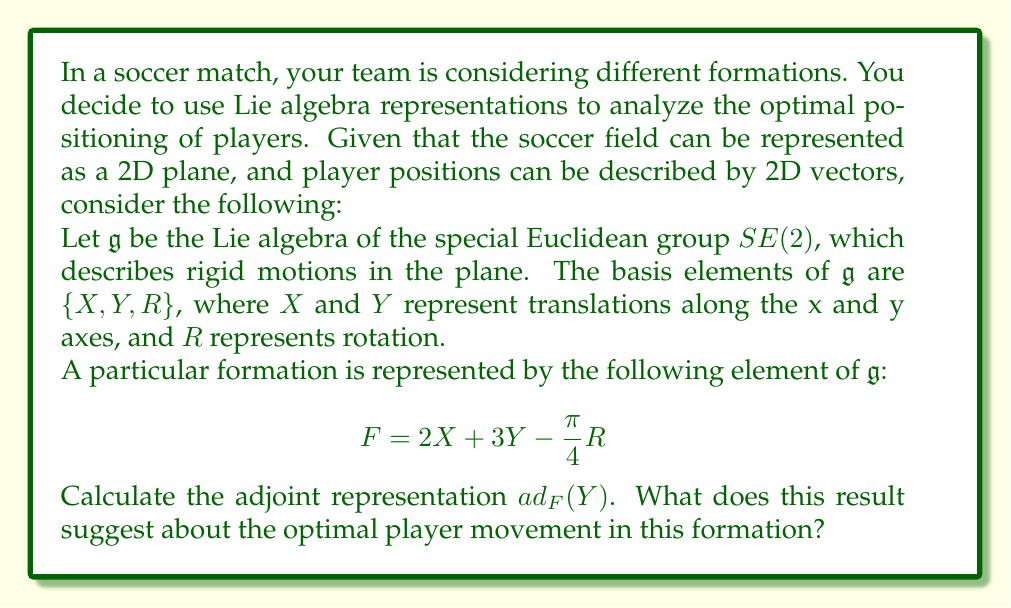Show me your answer to this math problem. To solve this problem, we'll follow these steps:

1) First, recall the commutation relations for the Lie algebra $\mathfrak{se}(2)$:
   
   $[X,Y] = 0$, $[X,R] = Y$, $[Y,R] = -X$

2) The adjoint representation $ad_F$ is a linear map defined by $ad_F(Z) = [F,Z]$ for any $Z \in \mathfrak{g}$

3) We need to calculate $ad_F(Y) = [F,Y] = [2X + 3Y - \frac{\pi}{4}R, Y]$

4) Using the linearity of the Lie bracket and the commutation relations:

   $[2X + 3Y - \frac{\pi}{4}R, Y]$ 
   $= 2[X,Y] + 3[Y,Y] - \frac{\pi}{4}[R,Y]$
   $= 0 + 0 + \frac{\pi}{4}X$
   $= \frac{\pi}{4}X$

5) Interpreting the result:
   The adjoint representation $ad_F(Y) = \frac{\pi}{4}X$ suggests that in this formation, a movement in the Y direction (forward/backward on the field) results in a transformation that includes a component in the X direction (left/right on the field).

6) In soccer terms, this implies that the optimal player movement in this formation involves diagonal runs. When a player moves forward or backward, they should also shift slightly to the side to maintain the formation's structure and create space.

This analysis helps the team understand how to maintain their shape and create effective attacking or defensive patterns based on the mathematical representation of their formation.
Answer: $ad_F(Y) = \frac{\pi}{4}X$

This result suggests that optimal player movement in this formation involves diagonal runs, combining forward/backward movement with lateral shifts to maintain formation structure and create space. 